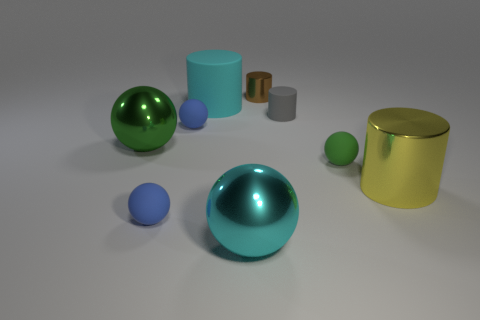There is a cyan object that is behind the big green ball; what size is it?
Your response must be concise. Large. What number of gray objects are either small rubber things or metallic things?
Ensure brevity in your answer.  1. There is a brown object that is the same shape as the small gray matte object; what material is it?
Ensure brevity in your answer.  Metal. Are there an equal number of metal cylinders that are left of the cyan matte thing and big gray shiny cylinders?
Provide a short and direct response. Yes. There is a sphere that is to the right of the big cyan cylinder and to the left of the small gray cylinder; what size is it?
Give a very brief answer. Large. Is there anything else that is the same color as the large matte object?
Provide a short and direct response. Yes. There is a green thing that is to the right of the metal cylinder left of the large yellow cylinder; what size is it?
Your response must be concise. Small. There is a big object that is to the left of the cyan ball and in front of the cyan rubber cylinder; what color is it?
Provide a succinct answer. Green. What number of other things are there of the same size as the brown thing?
Make the answer very short. 4. Does the gray rubber cylinder have the same size as the metal sphere that is in front of the big yellow metal cylinder?
Keep it short and to the point. No. 